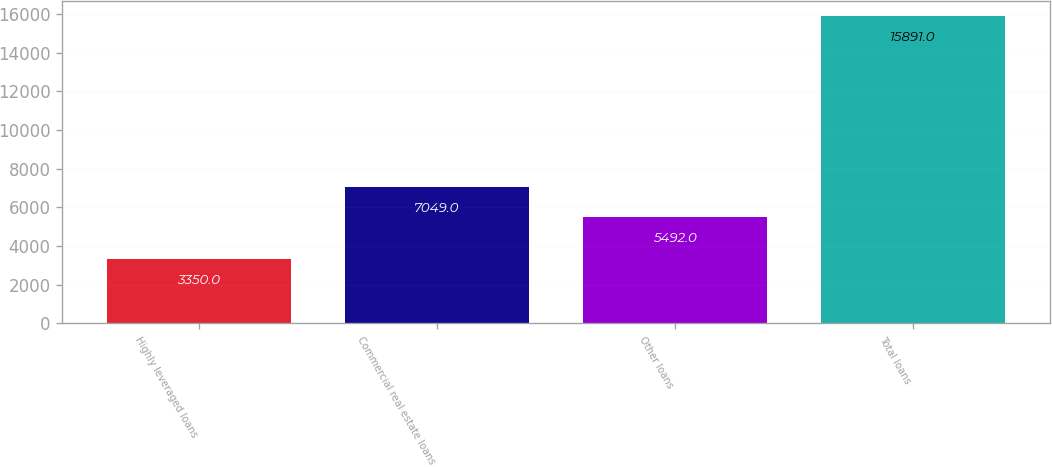Convert chart. <chart><loc_0><loc_0><loc_500><loc_500><bar_chart><fcel>Highly leveraged loans<fcel>Commercial real estate loans<fcel>Other loans<fcel>Total loans<nl><fcel>3350<fcel>7049<fcel>5492<fcel>15891<nl></chart> 